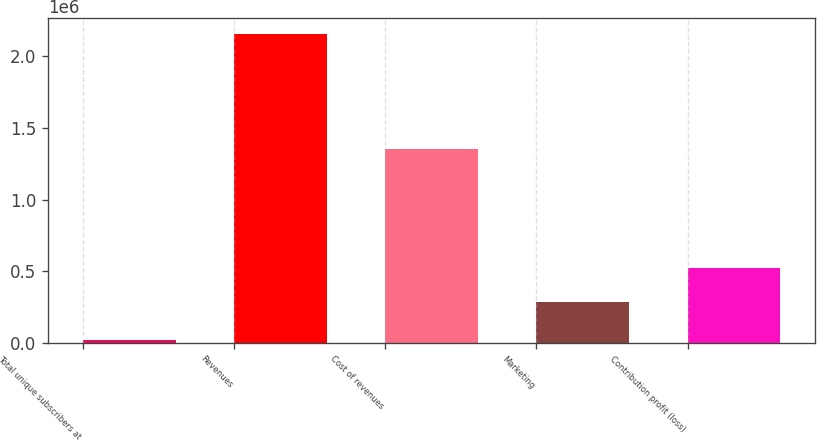<chart> <loc_0><loc_0><loc_500><loc_500><bar_chart><fcel>Total unique subscribers at<fcel>Revenues<fcel>Cost of revenues<fcel>Marketing<fcel>Contribution profit (loss)<nl><fcel>19501<fcel>2.15901e+06<fcel>1.35054e+06<fcel>284917<fcel>523549<nl></chart> 